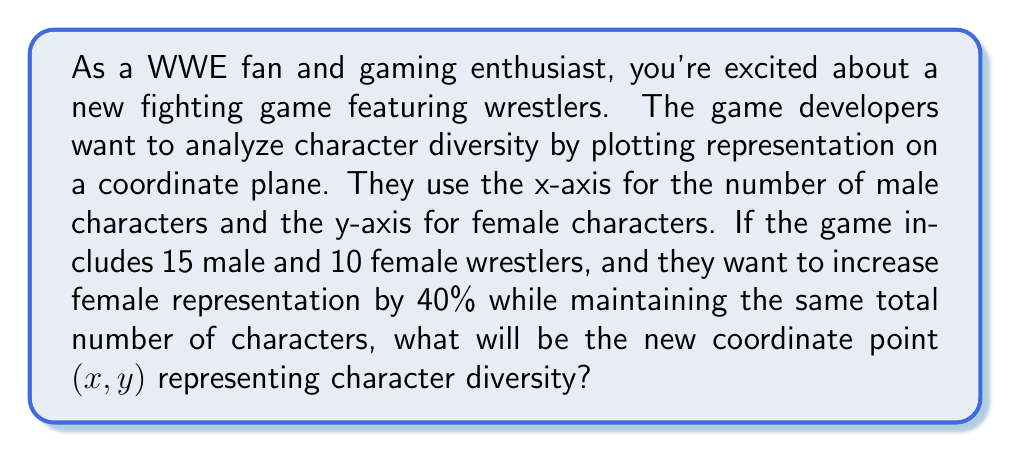Give your solution to this math problem. Let's approach this step-by-step:

1) Initially, we have:
   $x = 15$ (male characters)
   $y = 10$ (female characters)
   Total characters = $15 + 10 = 25$

2) We need to increase female representation by 40%:
   New number of female characters = $10 + (40\% \text{ of } 10) = 10 + 0.4 \times 10 = 14$

3) The total number of characters should remain the same (25), so:
   New number of male characters = $25 - 14 = 11$

4) Therefore, the new coordinate point will be:
   $x = 11$ (new number of male characters)
   $y = 14$ (new number of female characters)

We can verify:
$11 + 14 = 25$ (total characters remain the same)
$\frac{14 - 10}{10} \times 100\% = 40\%$ (female representation increased by 40%)

[asy]
size(200);
draw((-1,0)--(12,0),arrow=Arrow(TeXHead));
draw((0,-1)--(0,15),arrow=Arrow(TeXHead));
label("Male characters",(12,0),E);
label("Female characters",(0,15),N);
dot((15,10),red);
dot((11,14),blue);
label("(15,10)",(15,10),NE,red);
label("(11,14)",(11,14),NW,blue);
[/asy]
Answer: The new coordinate point representing character diversity will be $(11,14)$. 